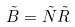Convert formula to latex. <formula><loc_0><loc_0><loc_500><loc_500>\tilde { B } = \tilde { N } \tilde { R }</formula> 